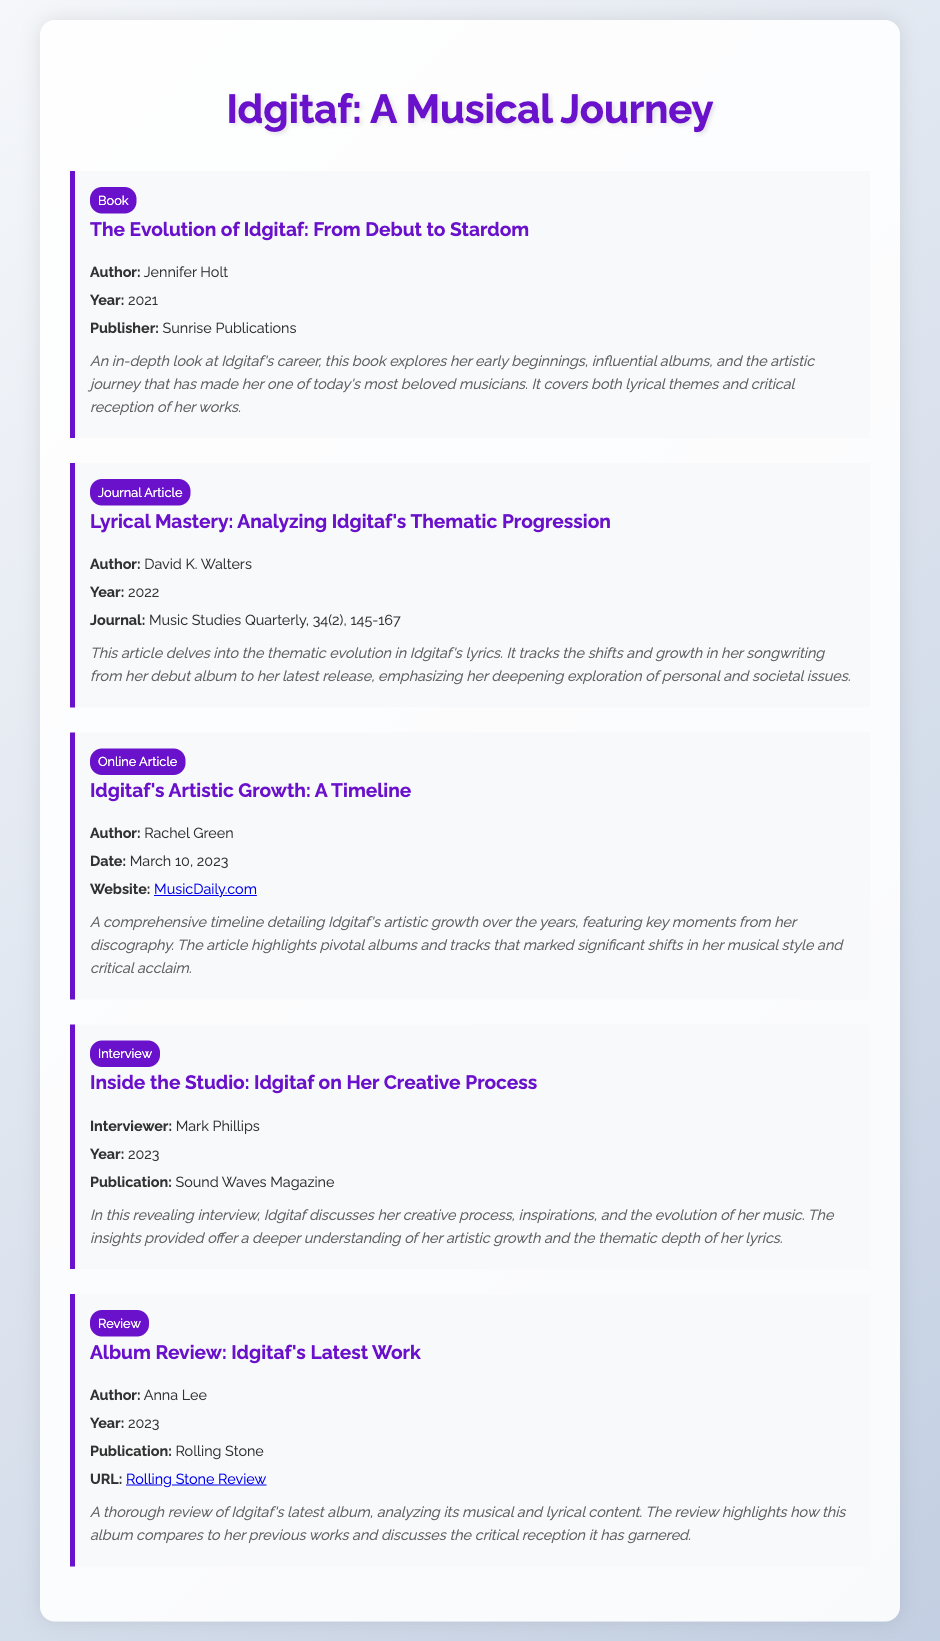What is the title of the book about Idgitaf? The title is explicitly listed as "The Evolution of Idgitaf: From Debut to Stardom."
Answer: The Evolution of Idgitaf: From Debut to Stardom Who is the author of the journal article analyzing Idgitaf's lyrics? The author's name is clearly mentioned as David K. Walters.
Answer: David K. Walters What year was Idgitaf's artistic growth timeline published? The publication date is included as March 10, 2023.
Answer: March 10, 2023 Which publication featured an interview with Idgitaf? The document specifies the publication as Sound Waves Magazine.
Answer: Sound Waves Magazine What is the main theme of the book by Jennifer Holt? The summary indicates the book explores Idgitaf's career, early beginnings, and artistic journey.
Answer: Idgitaf's career, early beginnings, and artistic journey What type of content does the latest album review cover? The summary describes it as analyzing musical and lyrical content.
Answer: Musical and lyrical content In what year was the journal article on Idgitaf's thematic progression published? The document states it was published in 2022.
Answer: 2022 What genre of document is "Inside the Studio: Idgitaf on Her Creative Process"? The document specifies it as an interview.
Answer: Interview 